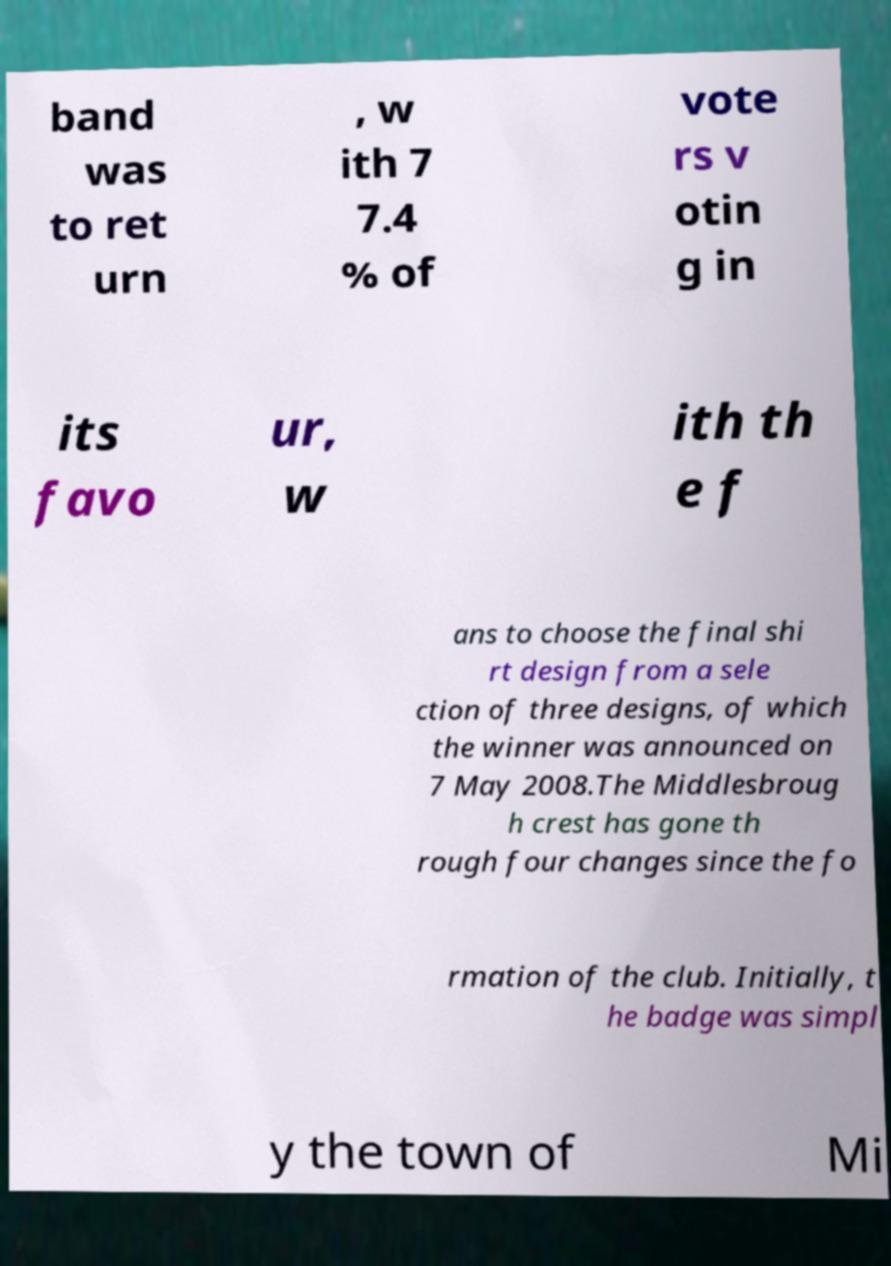Can you read and provide the text displayed in the image?This photo seems to have some interesting text. Can you extract and type it out for me? band was to ret urn , w ith 7 7.4 % of vote rs v otin g in its favo ur, w ith th e f ans to choose the final shi rt design from a sele ction of three designs, of which the winner was announced on 7 May 2008.The Middlesbroug h crest has gone th rough four changes since the fo rmation of the club. Initially, t he badge was simpl y the town of Mi 